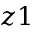<formula> <loc_0><loc_0><loc_500><loc_500>z 1</formula> 